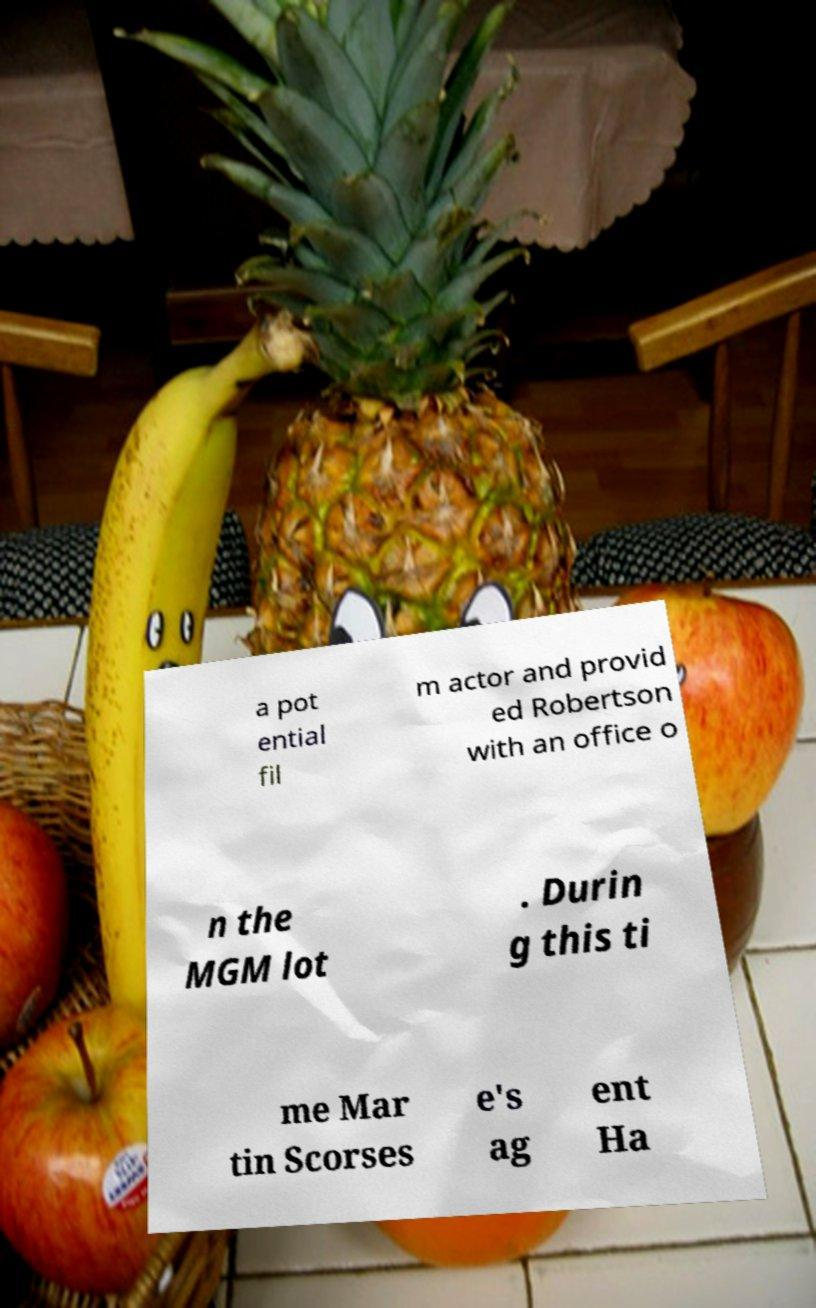There's text embedded in this image that I need extracted. Can you transcribe it verbatim? a pot ential fil m actor and provid ed Robertson with an office o n the MGM lot . Durin g this ti me Mar tin Scorses e's ag ent Ha 